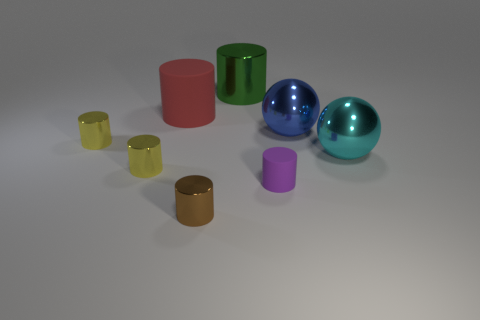Subtract all green cylinders. How many cylinders are left? 5 Subtract all purple cylinders. How many cylinders are left? 5 Add 1 metal things. How many objects exist? 9 Subtract all yellow cylinders. Subtract all cyan balls. How many cylinders are left? 4 Add 3 large green things. How many large green things are left? 4 Add 2 small objects. How many small objects exist? 6 Subtract 0 red cubes. How many objects are left? 8 Subtract all balls. How many objects are left? 6 Subtract all tiny blue shiny cylinders. Subtract all cylinders. How many objects are left? 2 